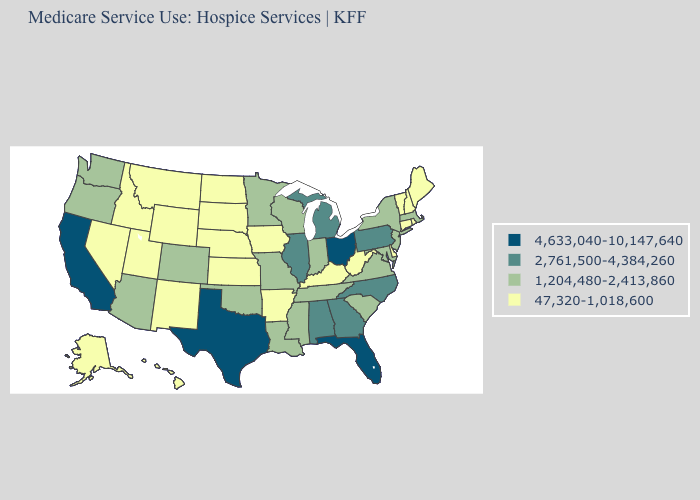What is the lowest value in the USA?
Answer briefly. 47,320-1,018,600. Name the states that have a value in the range 2,761,500-4,384,260?
Write a very short answer. Alabama, Georgia, Illinois, Michigan, North Carolina, Pennsylvania. What is the value of Massachusetts?
Short answer required. 1,204,480-2,413,860. Name the states that have a value in the range 4,633,040-10,147,640?
Short answer required. California, Florida, Ohio, Texas. Does the map have missing data?
Short answer required. No. How many symbols are there in the legend?
Concise answer only. 4. Among the states that border Wyoming , does South Dakota have the highest value?
Concise answer only. No. What is the lowest value in states that border Iowa?
Be succinct. 47,320-1,018,600. What is the value of Oregon?
Answer briefly. 1,204,480-2,413,860. Name the states that have a value in the range 1,204,480-2,413,860?
Write a very short answer. Arizona, Colorado, Indiana, Louisiana, Maryland, Massachusetts, Minnesota, Mississippi, Missouri, New Jersey, New York, Oklahoma, Oregon, South Carolina, Tennessee, Virginia, Washington, Wisconsin. What is the value of Virginia?
Short answer required. 1,204,480-2,413,860. Does Delaware have a lower value than Maine?
Give a very brief answer. No. Which states have the lowest value in the USA?
Write a very short answer. Alaska, Arkansas, Connecticut, Delaware, Hawaii, Idaho, Iowa, Kansas, Kentucky, Maine, Montana, Nebraska, Nevada, New Hampshire, New Mexico, North Dakota, Rhode Island, South Dakota, Utah, Vermont, West Virginia, Wyoming. Is the legend a continuous bar?
Quick response, please. No. What is the lowest value in the South?
Concise answer only. 47,320-1,018,600. 